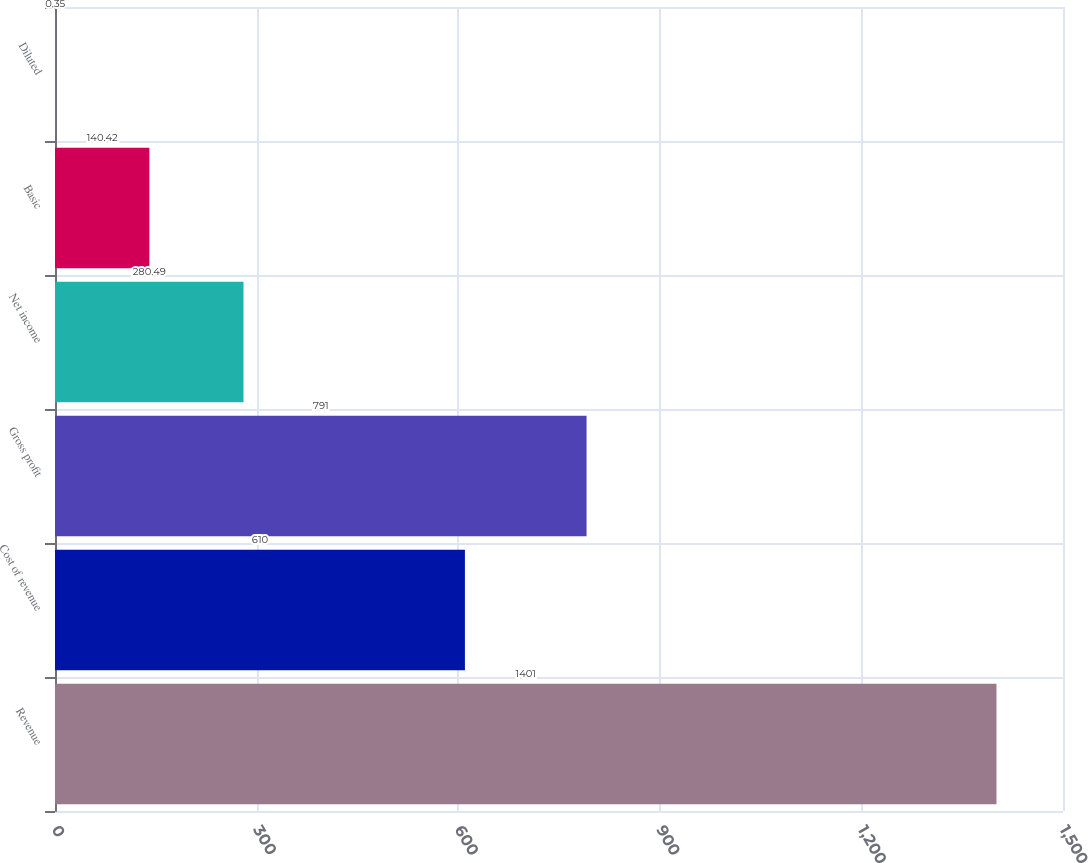<chart> <loc_0><loc_0><loc_500><loc_500><bar_chart><fcel>Revenue<fcel>Cost of revenue<fcel>Gross profit<fcel>Net income<fcel>Basic<fcel>Diluted<nl><fcel>1401<fcel>610<fcel>791<fcel>280.49<fcel>140.42<fcel>0.35<nl></chart> 